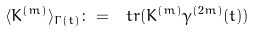Convert formula to latex. <formula><loc_0><loc_0><loc_500><loc_500>\langle K ^ { ( m ) } \rangle _ { \Gamma ( t ) } \colon = \ t r ( K ^ { ( m ) } \gamma ^ { ( 2 m ) } ( t ) )</formula> 